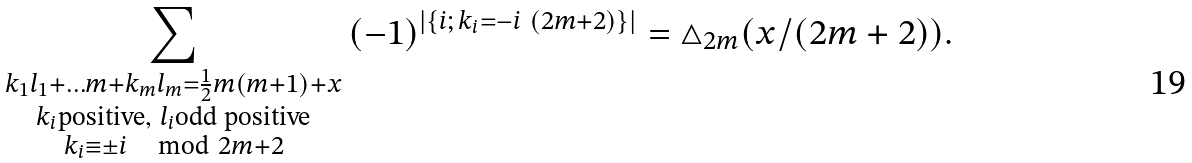Convert formula to latex. <formula><loc_0><loc_0><loc_500><loc_500>\sum _ { \substack { k _ { 1 } l _ { 1 } + \dots m + k _ { m } l _ { m } = \frac { 1 } { 2 } m ( m + 1 ) + x \\ k _ { i } \text {positive} , \ l _ { i } \text {odd    positive} \\ k _ { i } \equiv \pm i \, \mod 2 m + 2 } } \, ( - 1 ) ^ { | \{ i ; \, k _ { i } = - i \ ( 2 m + 2 ) \} | } = \triangle _ { 2 m } ( x / ( 2 m + 2 ) ) .</formula> 